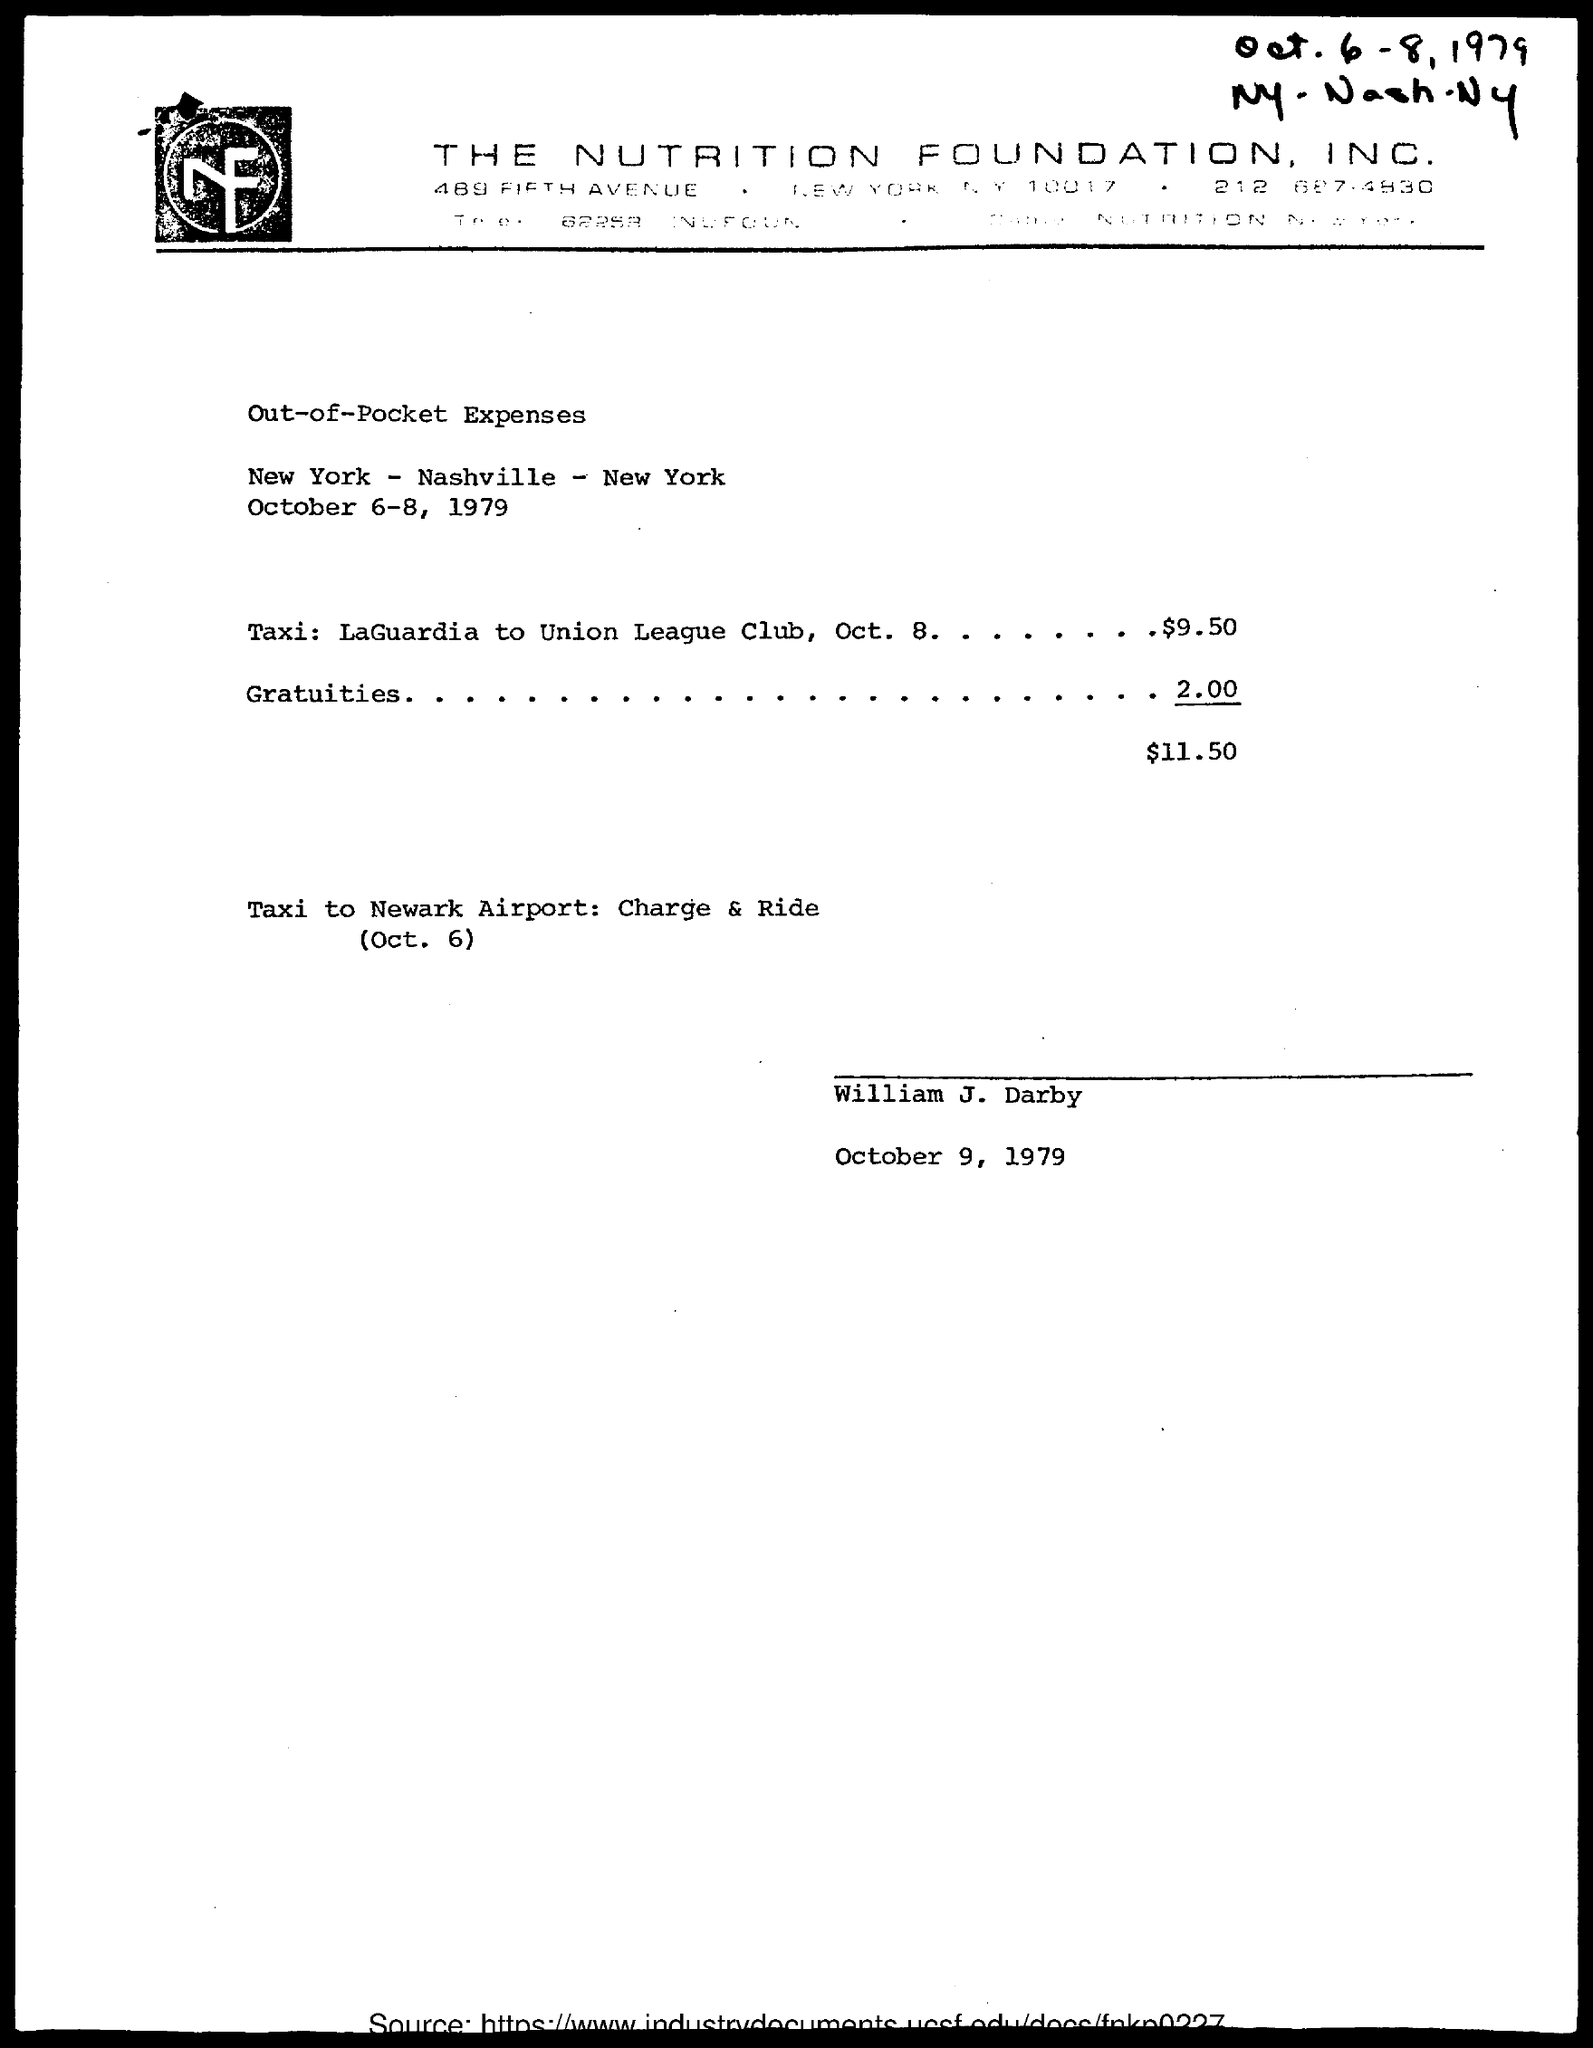List a handful of essential elements in this visual. On October 8, the taxi fare from LaGuardia to the Union League Club was $9.50. The date on the document is October 6-8, 1979. The amount for gratuities is 2.00. 